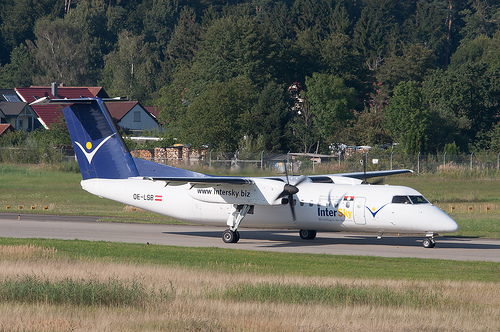Please provide a short description for this region: [0.75, 0.19, 0.82, 0.27]. The region from coordinates [0.75, 0.19, 0.82, 0.27] features 'Green leaves in brown trees,' indicating a cluster of foliage set against a contrasting background of tree trunks. 